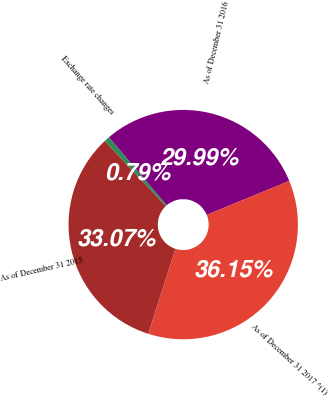Convert chart to OTSL. <chart><loc_0><loc_0><loc_500><loc_500><pie_chart><fcel>As of December 31 2015<fcel>Exchange rate changes<fcel>As of December 31 2016<fcel>As of December 31 2017 ^(1)<nl><fcel>33.07%<fcel>0.79%<fcel>29.99%<fcel>36.15%<nl></chart> 